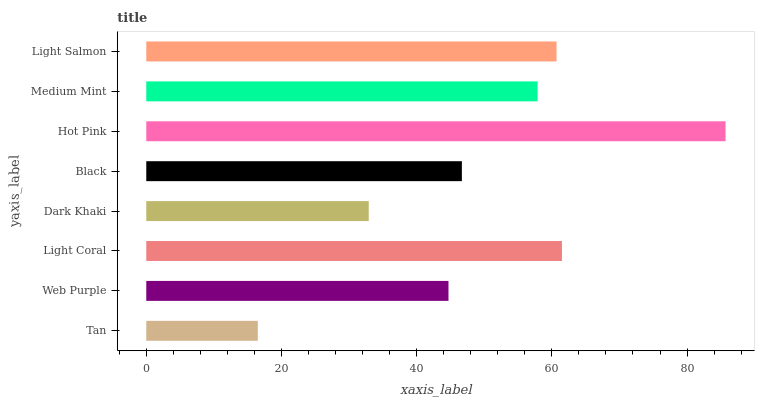Is Tan the minimum?
Answer yes or no. Yes. Is Hot Pink the maximum?
Answer yes or no. Yes. Is Web Purple the minimum?
Answer yes or no. No. Is Web Purple the maximum?
Answer yes or no. No. Is Web Purple greater than Tan?
Answer yes or no. Yes. Is Tan less than Web Purple?
Answer yes or no. Yes. Is Tan greater than Web Purple?
Answer yes or no. No. Is Web Purple less than Tan?
Answer yes or no. No. Is Medium Mint the high median?
Answer yes or no. Yes. Is Black the low median?
Answer yes or no. Yes. Is Light Coral the high median?
Answer yes or no. No. Is Light Coral the low median?
Answer yes or no. No. 